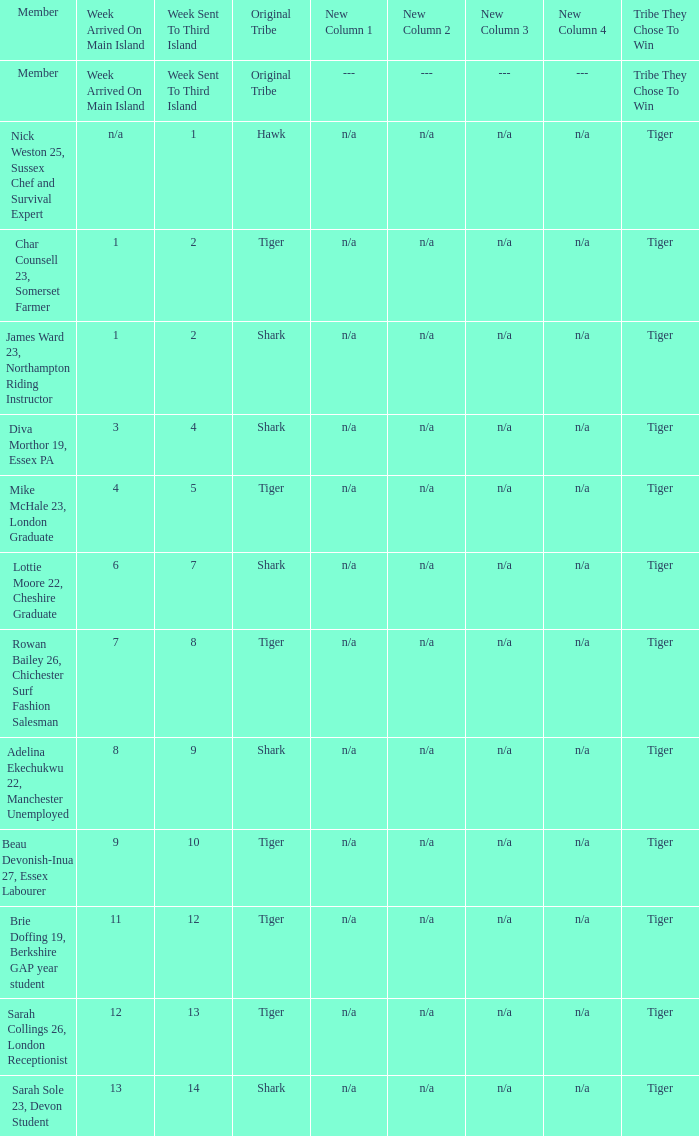Who was sent to the third island in week 1? Nick Weston 25, Sussex Chef and Survival Expert. 